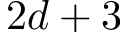Convert formula to latex. <formula><loc_0><loc_0><loc_500><loc_500>2 d + 3</formula> 